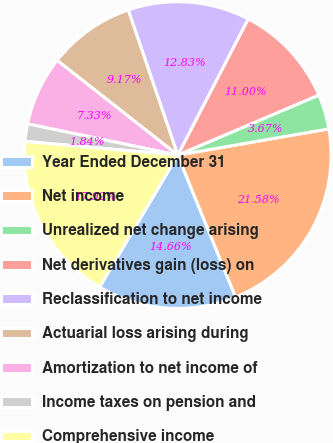<chart> <loc_0><loc_0><loc_500><loc_500><pie_chart><fcel>Year Ended December 31<fcel>Net income<fcel>Unrealized net change arising<fcel>Net derivatives gain (loss) on<fcel>Reclassification to net income<fcel>Actuarial loss arising during<fcel>Amortization to net income of<fcel>Income taxes on pension and<fcel>Comprehensive income<nl><fcel>14.66%<fcel>21.58%<fcel>3.67%<fcel>11.0%<fcel>12.83%<fcel>9.17%<fcel>7.33%<fcel>1.84%<fcel>17.92%<nl></chart> 